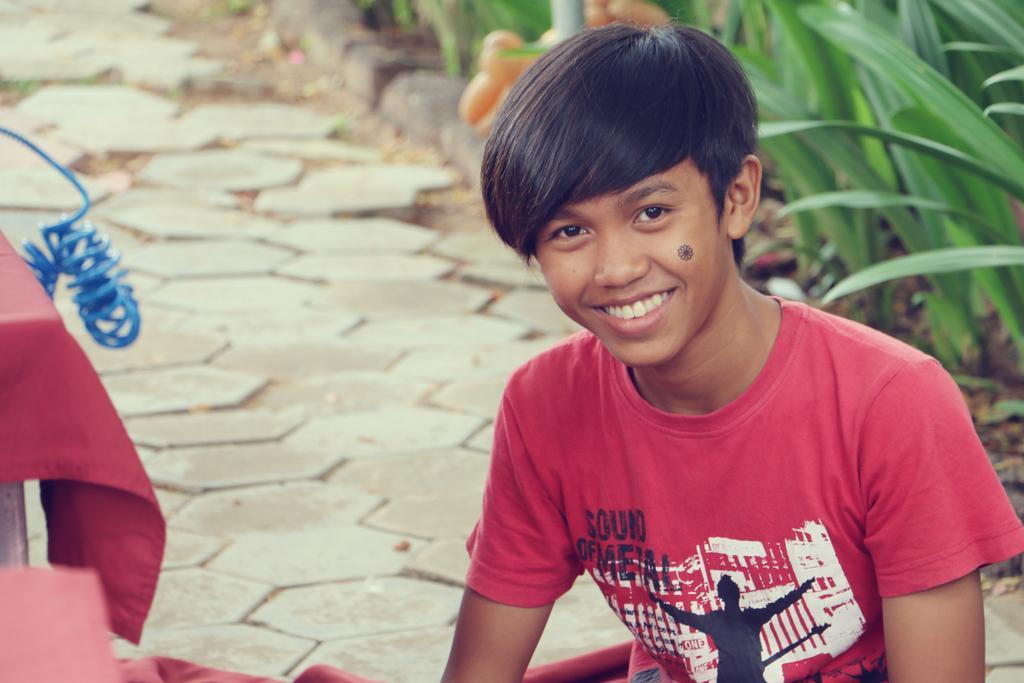Could you give a brief overview of what you see in this image? In this image we can see a person sitting, on the right side, we can see some plants and on the left side, we can see the table which is covered by the cloth. 